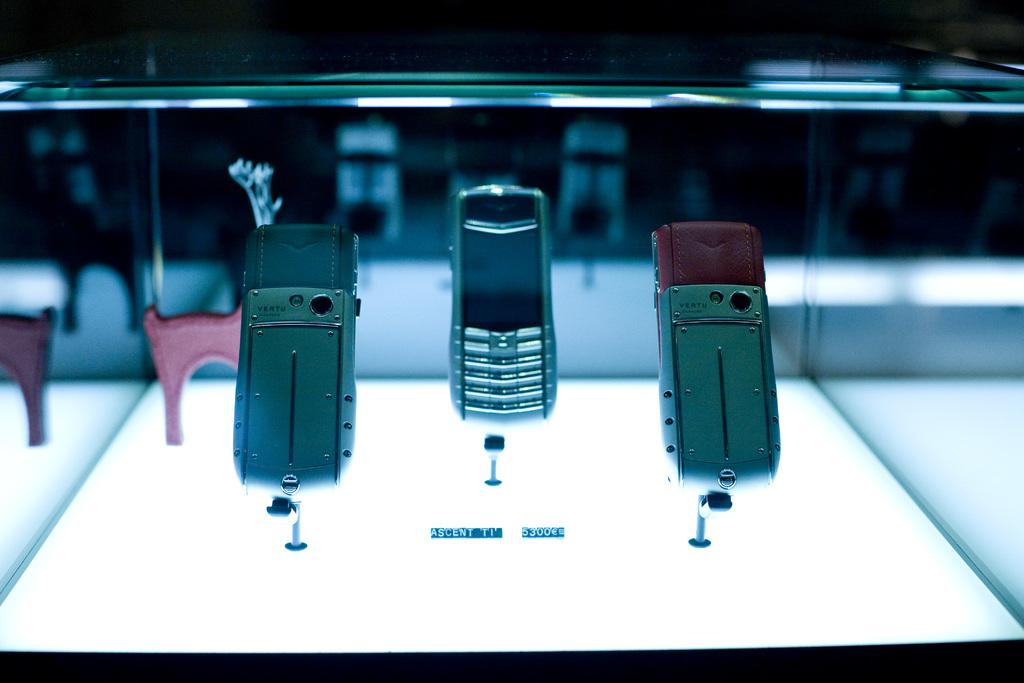<image>
Relay a brief, clear account of the picture shown. Three phones, under which the word Ascent can be seen. 